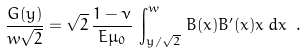Convert formula to latex. <formula><loc_0><loc_0><loc_500><loc_500>\frac { G ( y ) } { w \sqrt { 2 } } = \sqrt { 2 } \, \frac { 1 - \nu } { E \mu _ { 0 } } \, \int _ { y / \sqrt { 2 } } ^ { w } \, B ( x ) B ^ { \prime } ( x ) x \, d x \ .</formula> 